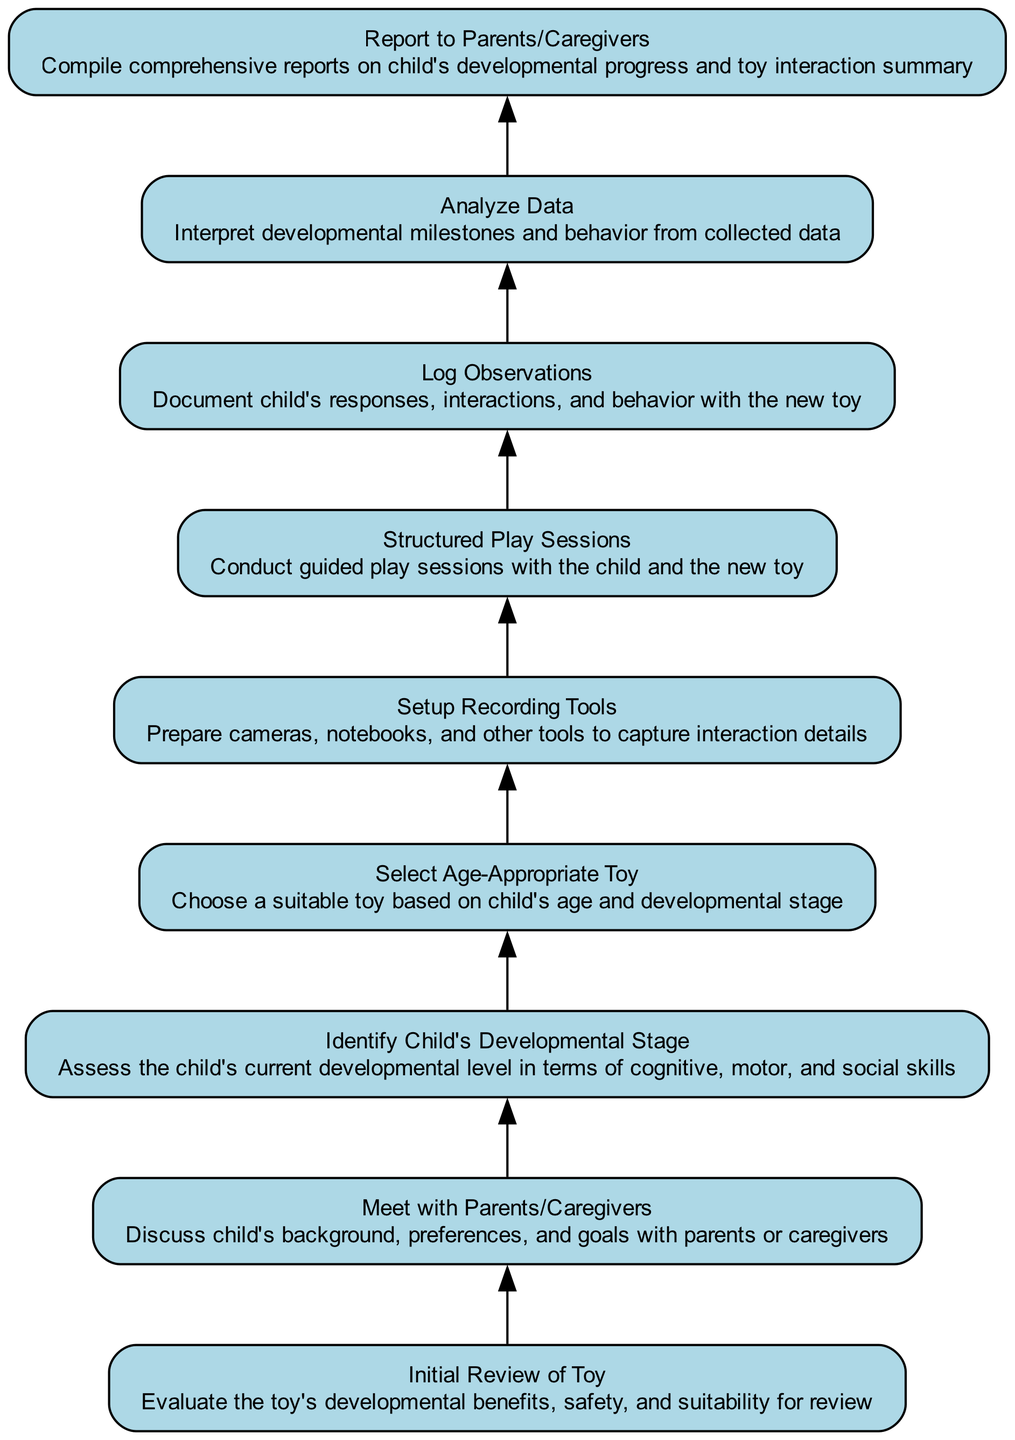What is the top node in the flowchart? The top node is "Report to Parents/Caregivers," which is the final step after all other actions in the flowchart have been completed. It serves as the conclusion of the process outlined by the diagram.
Answer: Report to Parents/Caregivers How many nodes are present in the diagram? By counting each distinct action or step within the flowchart, there are a total of 9 nodes. Each node represents an important action in the process of reviewing a child's development.
Answer: 9 What action occurs just before "Analyze Data"? The action that occurs just before "Analyze Data" is "Log Observations." This means that the observations need to be documented before any analysis can take place.
Answer: Log Observations What is the purpose of the "Select Age-Appropriate Toy" step? The purpose of "Select Age-Appropriate Toy" is to ensure that the chosen toy aligns with the child's age and developmental stage, promoting effective interaction and learning. This comes after assessing the child's developmental stage.
Answer: Choose a suitable toy based on child's age and developmental stage Which step follows "Structured Play Sessions"? The step that follows "Structured Play Sessions" is "Log Observations." After the play sessions, observations must be documented to assess the child's responses and behaviors.
Answer: Log Observations What is the relationship between "Identify Child's Developmental Stage" and "Select Age-Appropriate Toy"? "Identify Child's Developmental Stage" informs the next step "Select Age-Appropriate Toy," as the assessment of the child’s needs and skills helps determine which toy to select based on age appropriateness.
Answer: Inform selection of toy Which step is the initial action in the process? The initial action in the process is "Initial Review of Toy," which is the starting point before any interactions or observations take place with the child.
Answer: Initial Review of Toy How is "Meet with Parents/Caregivers" related to the entire process? "Meet with Parents/Caregivers" is an early step that gathers essential information about the child’s background, which sets the foundation for all subsequent steps in the process of developmental assessment.
Answer: Sets the foundation for assessment What happens directly after "Setup Recording Tools"? Directly after "Setup Recording Tools," the next action is "Structured Play Sessions." This means that recording tools need to be ready before guided sessions can be conducted.
Answer: Structured Play Sessions What is analyzed in the "Analyze Data" step? In the "Analyze Data" step, the behavior and developmental milestones observed during interactions with the toy are interpreted and assessed for progress.
Answer: Developmental milestones and behavior 